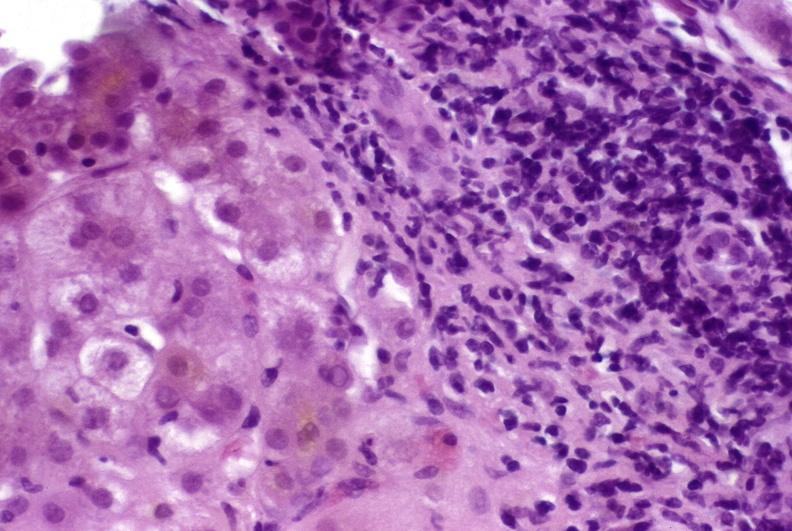s normal newborn present?
Answer the question using a single word or phrase. No 